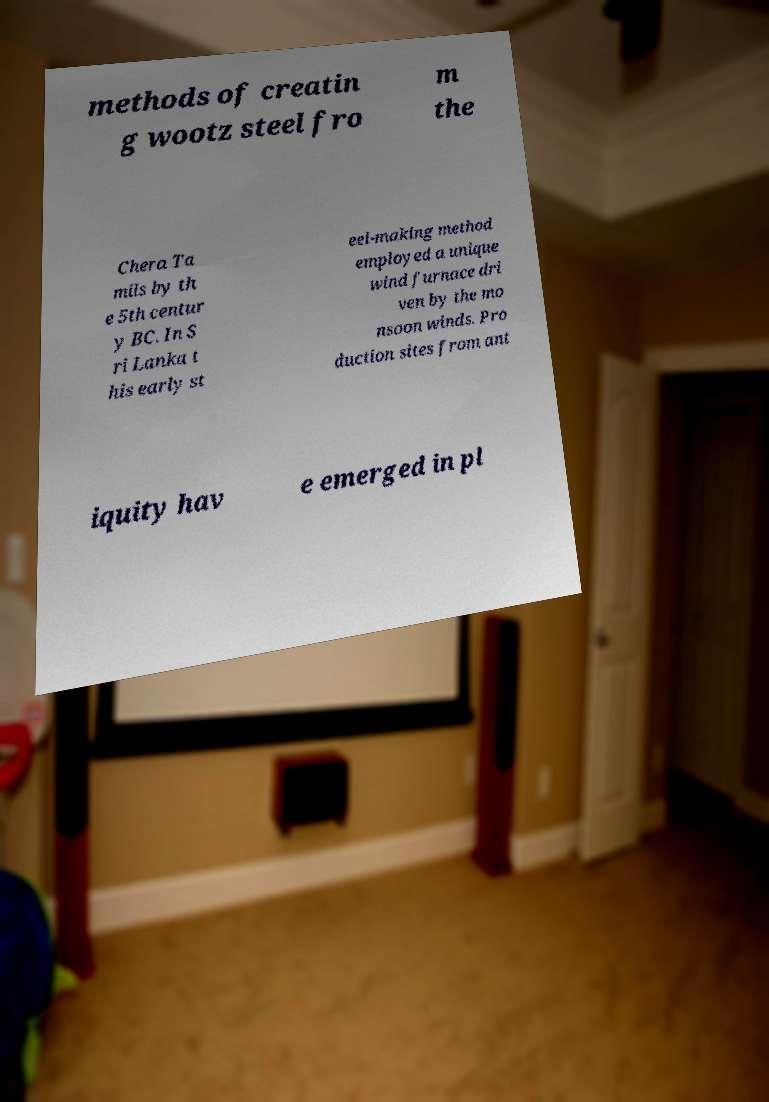Please read and relay the text visible in this image. What does it say? methods of creatin g wootz steel fro m the Chera Ta mils by th e 5th centur y BC. In S ri Lanka t his early st eel-making method employed a unique wind furnace dri ven by the mo nsoon winds. Pro duction sites from ant iquity hav e emerged in pl 